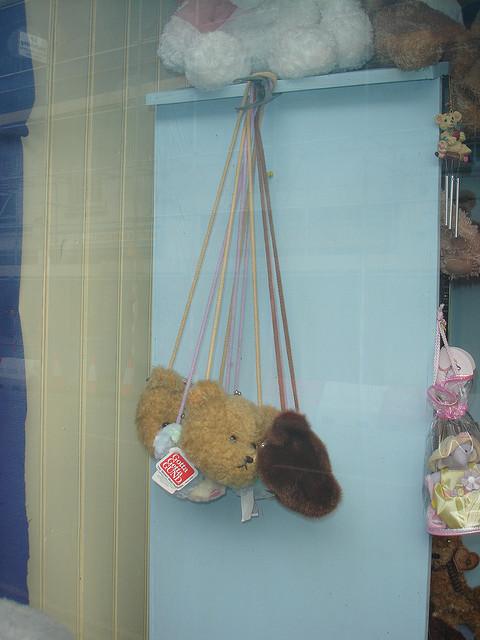What is the bear suspended from?
Keep it brief. Rope. What color is the smallest bear in the picture?
Concise answer only. Brown. Who usually has several stuffed animals in a room?
Short answer required. Children. 